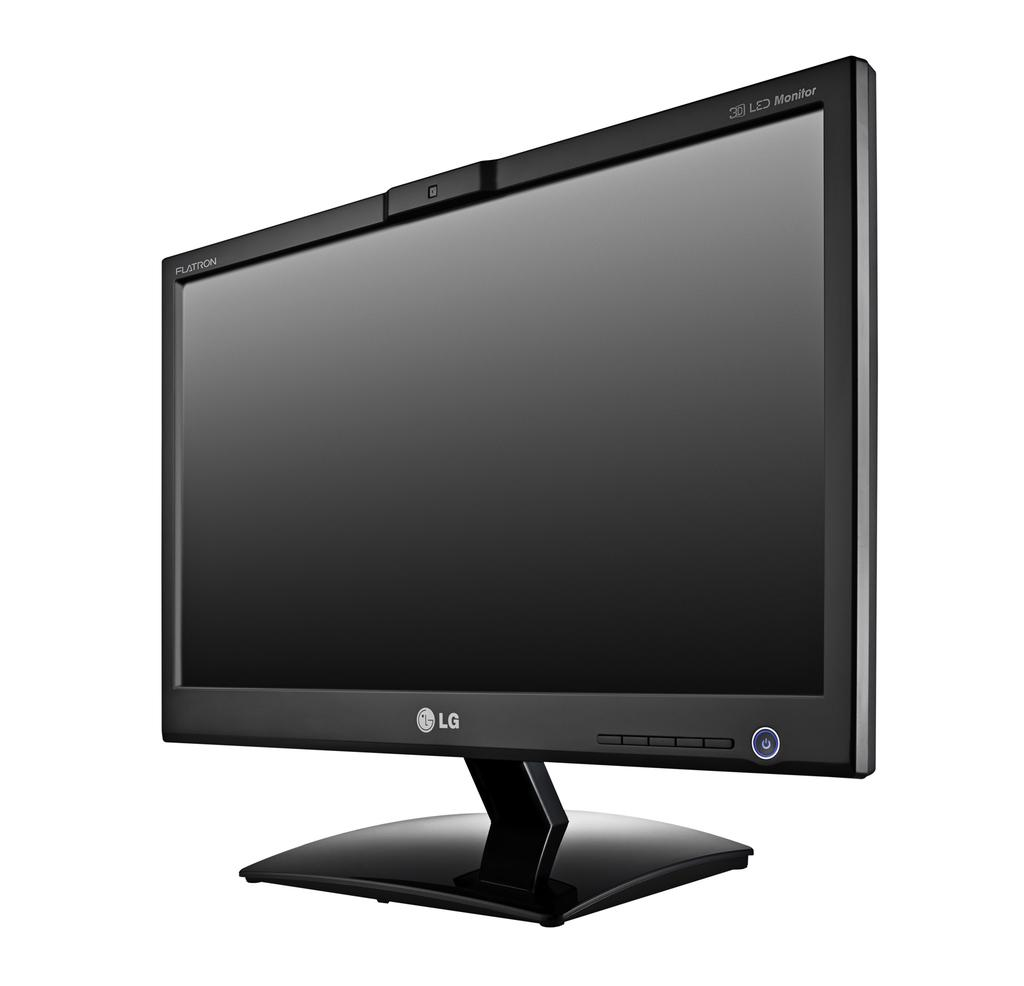What is the main object in the image? There is a monitor in the image. What color is the background of the image? The background of the image is white. What type of dinner is being served in the image? There is no dinner present in the image; it only features a monitor with a white background. 